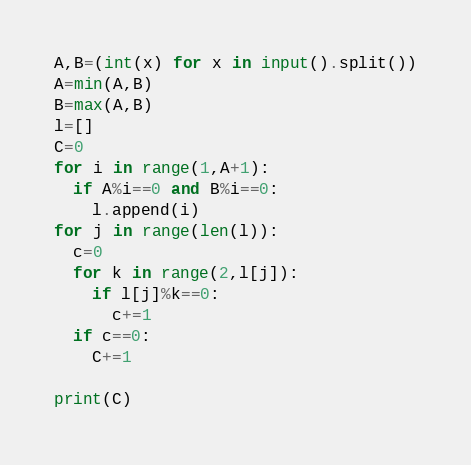<code> <loc_0><loc_0><loc_500><loc_500><_Python_>A,B=(int(x) for x in input().split())
A=min(A,B)
B=max(A,B)
l=[]
C=0
for i in range(1,A+1):
  if A%i==0 and B%i==0:
    l.append(i)
for j in range(len(l)):
  c=0
  for k in range(2,l[j]):
    if l[j]%k==0:
      c+=1
  if c==0:
    C+=1
       
print(C)
</code> 